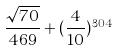Convert formula to latex. <formula><loc_0><loc_0><loc_500><loc_500>\frac { \sqrt { 7 0 } } { 4 6 9 } + ( \frac { 4 } { 1 0 } ) ^ { 3 0 4 }</formula> 